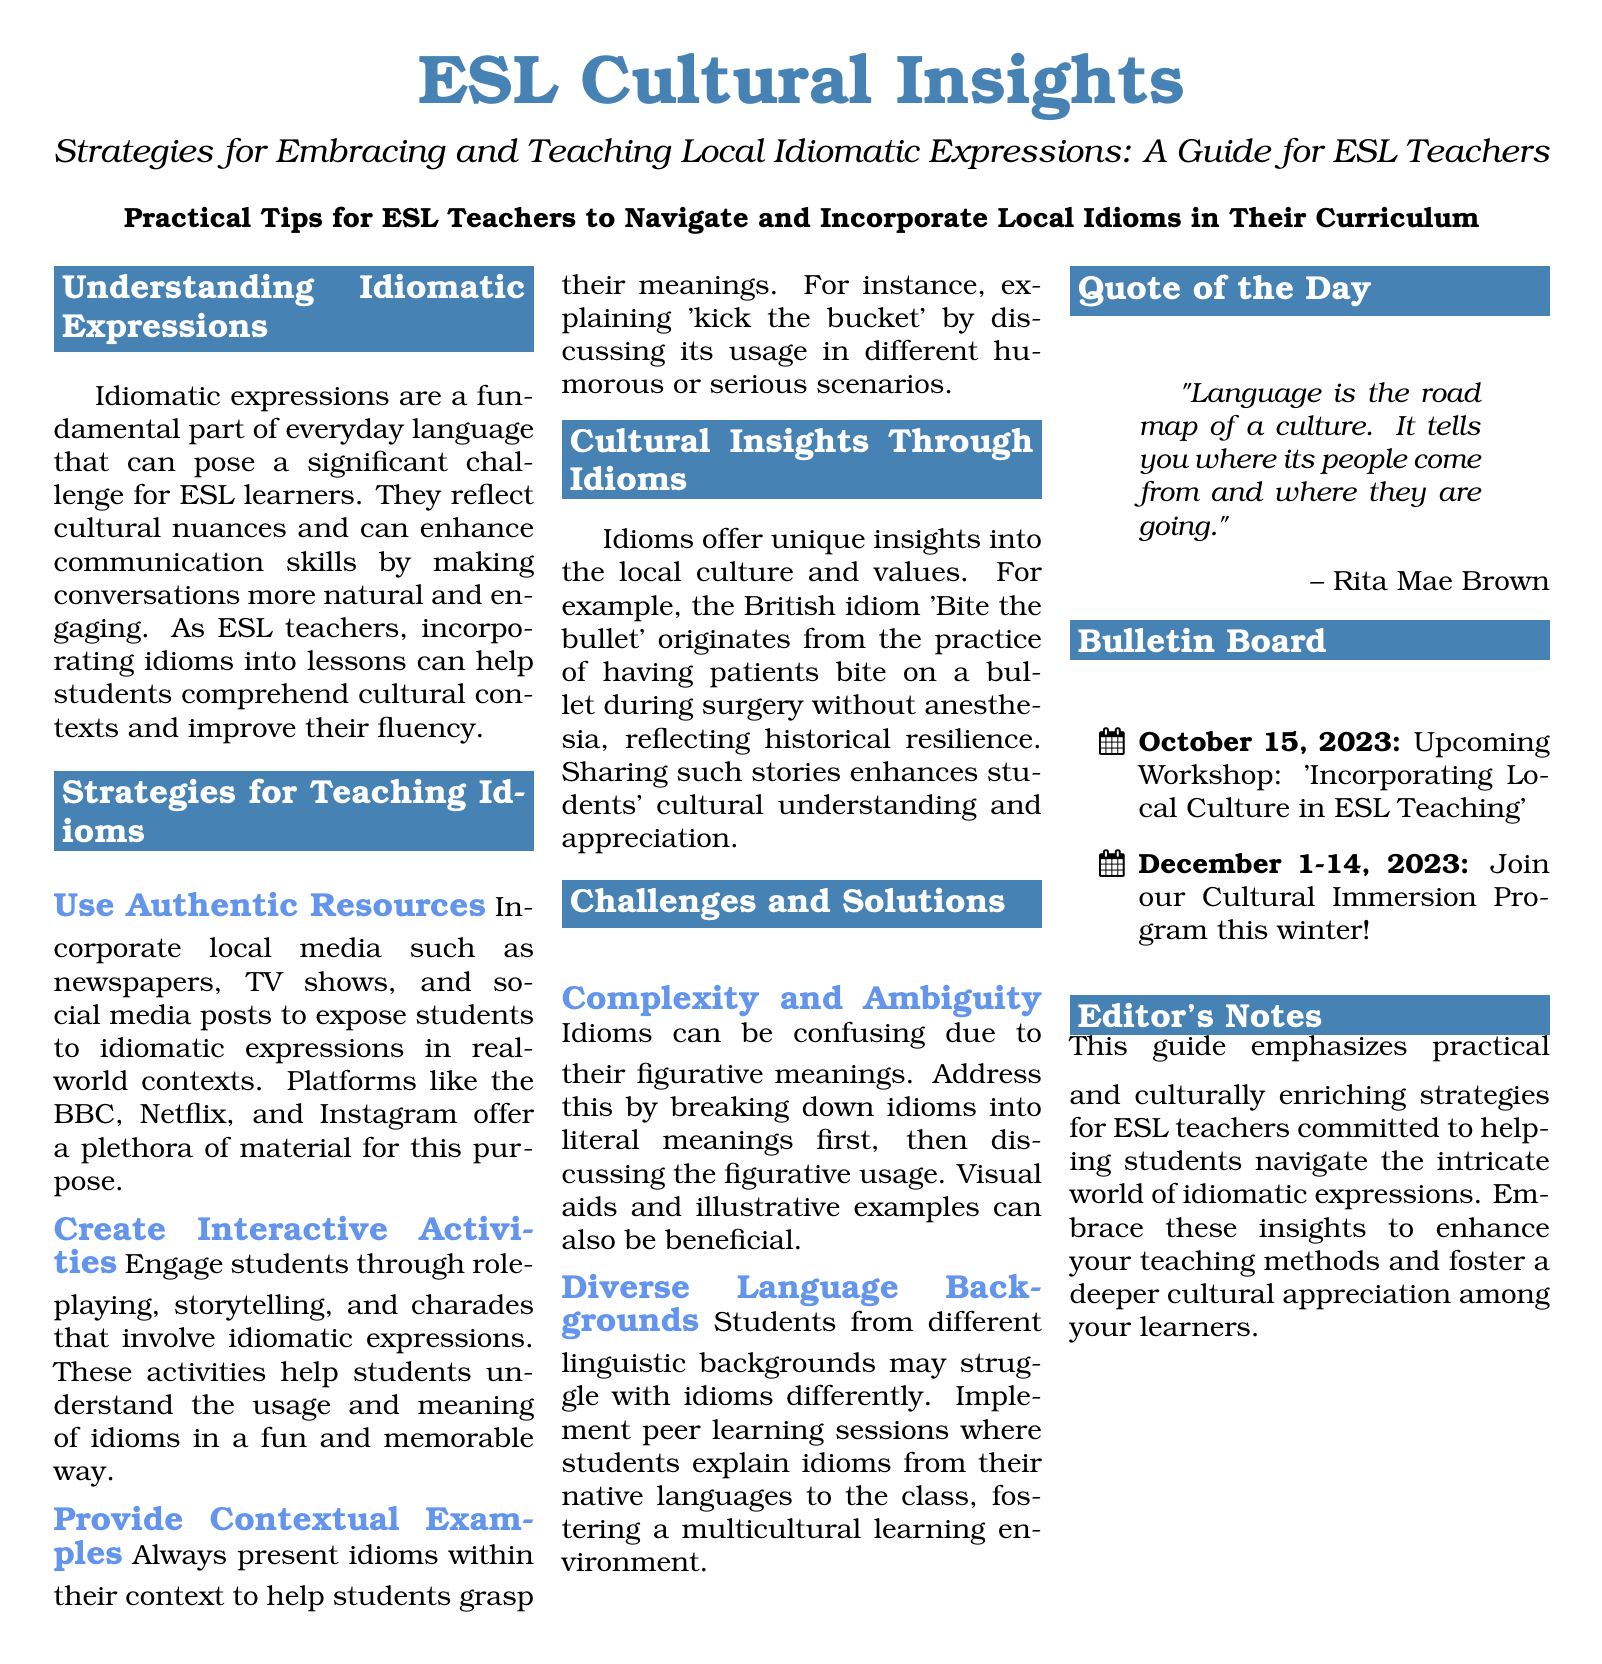What is the title of the document? The title is presented at the top of the document in a prominent format.
Answer: Strategies for Embracing and Teaching Local Idiomatic Expressions: A Guide for ESL Teachers What is the color of the heading? The heading color is defined earlier in the document using RGB values.
Answer: RGB(70,130,180) What date is the upcoming workshop scheduled for? The date is listed in the bulletin board section of the document.
Answer: October 15, 2023 What idiom is explained in the document as an example? The document provides specific idioms for teaching, including contextual examples.
Answer: kick the bucket What challenge related to idioms is mentioned? The document specifies challenges ESL teachers may face when teaching idioms.
Answer: Complexity and Ambiguity What type of activities are suggested to teach idioms interactively? The document suggests engaging methods to help understand idioms through different activities.
Answer: Role-playing How many sections does the document have on strategies? The document outlines different strategies for teaching idioms, which can be counted in their sections.
Answer: Three What quote is included in the document? The quote is featured prominently to convey a cultural insight related to language.
Answer: "Language is the road map of a culture. It tells you where its people come from and where they are going." Which program is mentioned for winter participation? This program offers an opportunity for cultural exchange and immersion as mentioned in the bulletin board.
Answer: Cultural Immersion Program 